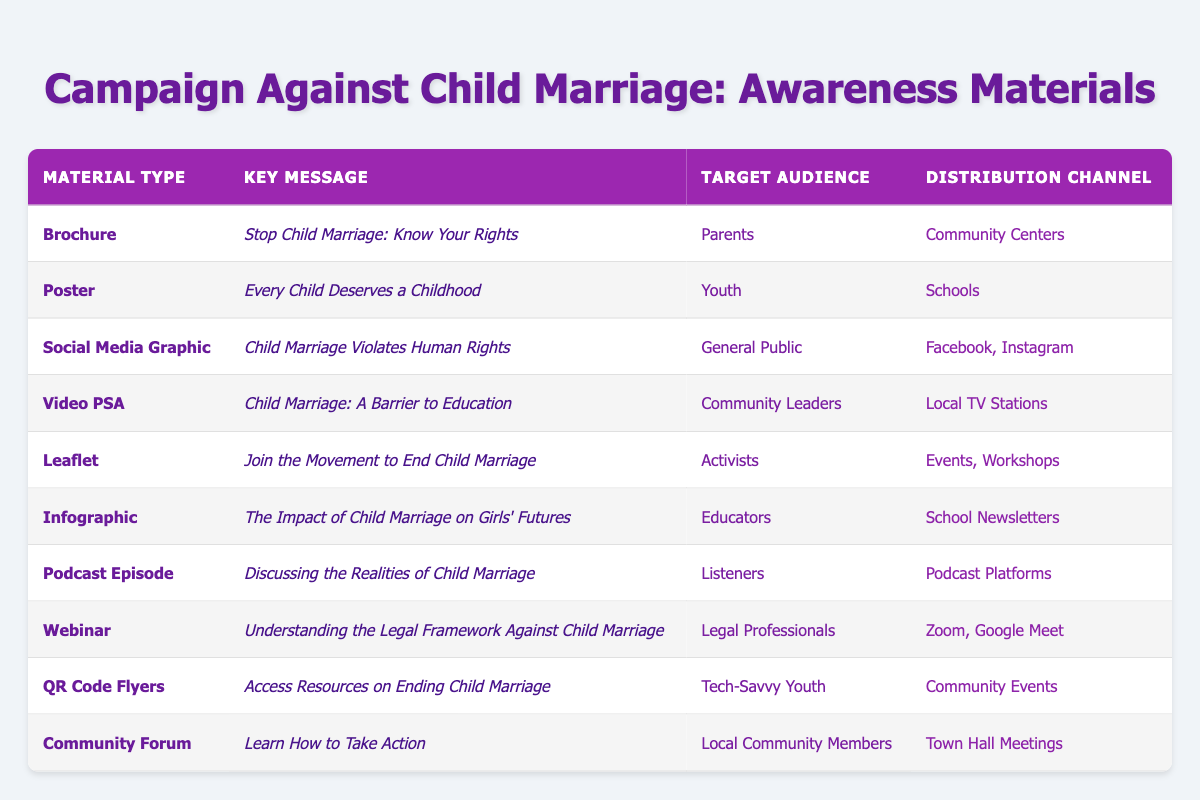What is the key message of the Poster material? The key message of the Poster material is "Every Child Deserves a Childhood." This can be found directly in the corresponding row of the table under the "Key Message" column for the material type "Poster."
Answer: Every Child Deserves a Childhood Which target audience is reached by the Brochure? The Brochure targets "Parents." This information is clearly indicated in the table under the "Target Audience" column for the material type "Brochure."
Answer: Parents How many different distribution channels are listed for the campaign materials? The table lists several unique distribution channels: Community Centers, Schools, Facebook, Instagram, Local TV Stations, Events, Workshops, School Newsletters, Podcast Platforms, Zoom, Google Meet, Community Events, and Town Hall Meetings. Counting these, there are 11 unique distribution channels.
Answer: 11 Is there any material targeting Activists? Yes, there is a material targeting Activists, specifically the "Leaflet" material. This can be confirmed by looking at the "Target Audience" column in the table for the corresponding material type.
Answer: Yes Which material is aimed at Community Leaders? The material aimed at Community Leaders is the "Video PSA." This is found from the table by locating the row with "Community Leaders" in the "Target Audience" column and checking the corresponding "Material Type."
Answer: Video PSA How many materials are designed for youth-related audiences (Youth and Tech-Savvy Youth)? The materials designed for youth-related audiences are the "Poster" targeting Youth and the "QR Code Flyers" targeting Tech-Savvy Youth. Two materials fit this criterion, as we count these specific entries under the "Target Audience" column.
Answer: 2 What messages are communicated to Educators through the campaign materials? The message communicated to Educators is "The Impact of Child Marriage on Girls' Futures." This can be found in the row of the "Infographic" material under the "Key Message" column relevant to the audience "Educators."
Answer: The Impact of Child Marriage on Girls' Futures Which distribution channel is most common in the campaign materials? Looking through the data, the most common distribution channels are "Community Events" and "Events, Workshops," but they are different in their descriptions. The other channels do not repeat as often. Therefore, there is no one predominant channel since each only appears once in a unique context.
Answer: None What is the total number of audience types specified in the campaign materials? The unique audience types specified are Parents, Youth, General Public, Community Leaders, Activists, Educators, Listeners, Legal Professionals, Tech-Savvy Youth, and Local Community Members, which totals 10 different audience types.
Answer: 10 What material type is distributed through Schools? The material type distributed through Schools is the "Poster." This is directly stated in the table where it shows Schools as the distribution channel for the specified material type.
Answer: Poster 